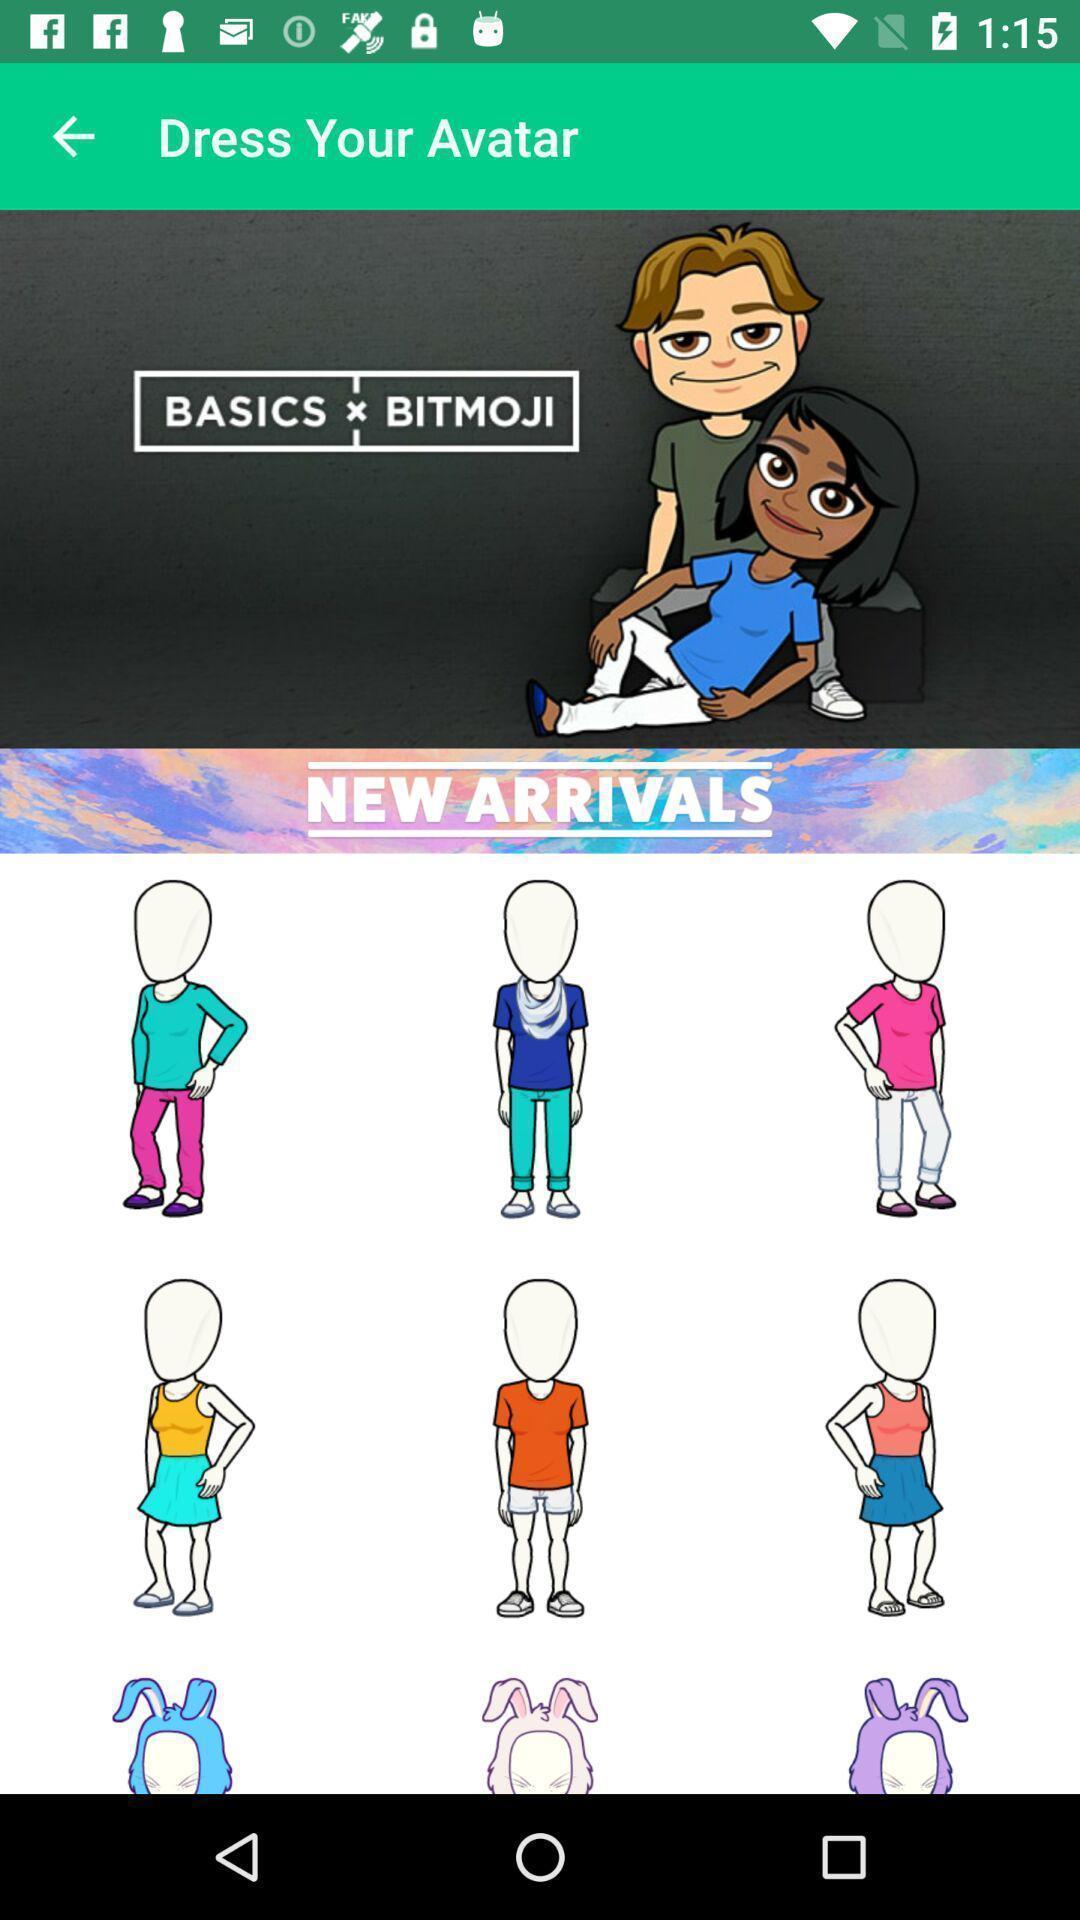What can you discern from this picture? Showing the list of avatar. 